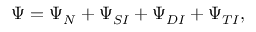<formula> <loc_0><loc_0><loc_500><loc_500>\Psi = \Psi _ { N } + \Psi _ { S I } + \Psi _ { D I } + \Psi _ { T I } ,</formula> 